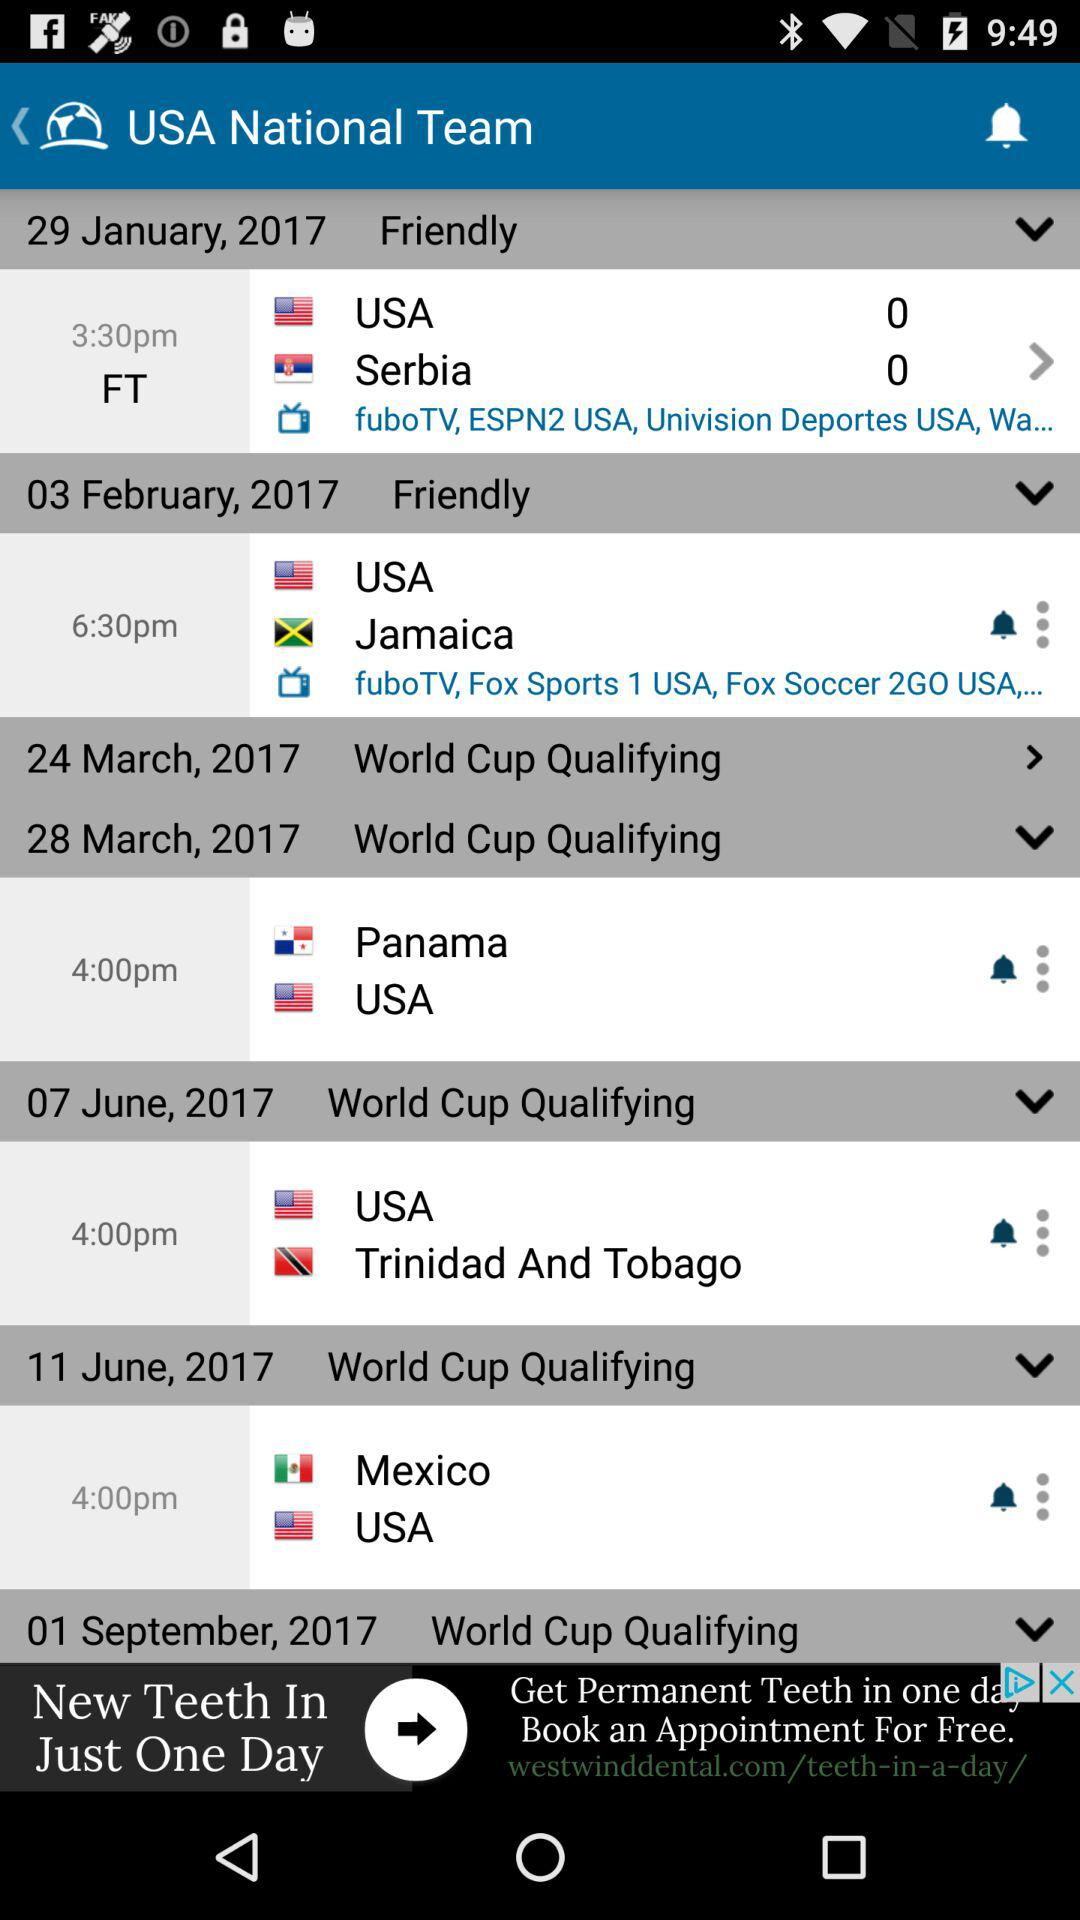What time is the match between "Panama" and the "USA" on March 28th? The match between "Panama" and the "USA" is at 4 p.m. 